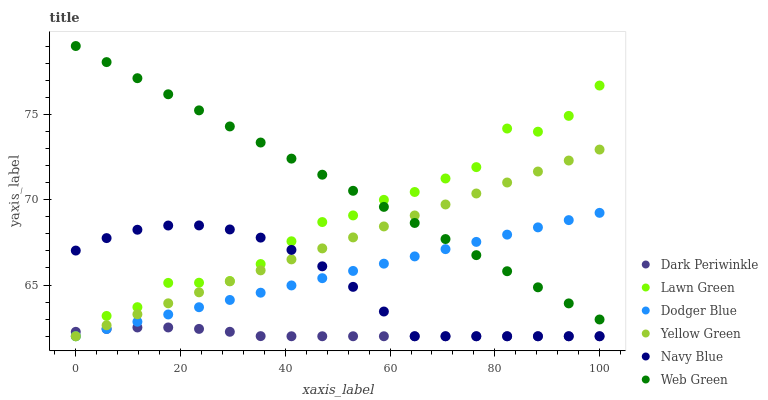Does Dark Periwinkle have the minimum area under the curve?
Answer yes or no. Yes. Does Web Green have the maximum area under the curve?
Answer yes or no. Yes. Does Yellow Green have the minimum area under the curve?
Answer yes or no. No. Does Yellow Green have the maximum area under the curve?
Answer yes or no. No. Is Dodger Blue the smoothest?
Answer yes or no. Yes. Is Lawn Green the roughest?
Answer yes or no. Yes. Is Yellow Green the smoothest?
Answer yes or no. No. Is Yellow Green the roughest?
Answer yes or no. No. Does Lawn Green have the lowest value?
Answer yes or no. Yes. Does Web Green have the lowest value?
Answer yes or no. No. Does Web Green have the highest value?
Answer yes or no. Yes. Does Yellow Green have the highest value?
Answer yes or no. No. Is Navy Blue less than Web Green?
Answer yes or no. Yes. Is Web Green greater than Dark Periwinkle?
Answer yes or no. Yes. Does Yellow Green intersect Lawn Green?
Answer yes or no. Yes. Is Yellow Green less than Lawn Green?
Answer yes or no. No. Is Yellow Green greater than Lawn Green?
Answer yes or no. No. Does Navy Blue intersect Web Green?
Answer yes or no. No. 